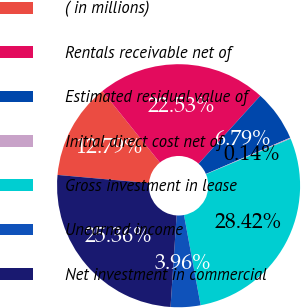Convert chart to OTSL. <chart><loc_0><loc_0><loc_500><loc_500><pie_chart><fcel>( in millions)<fcel>Rentals receivable net of<fcel>Estimated residual value of<fcel>Initial direct cost net of<fcel>Gross investment in lease<fcel>Unearned income<fcel>Net investment in commercial<nl><fcel>12.79%<fcel>22.53%<fcel>6.79%<fcel>0.14%<fcel>28.42%<fcel>3.96%<fcel>25.36%<nl></chart> 